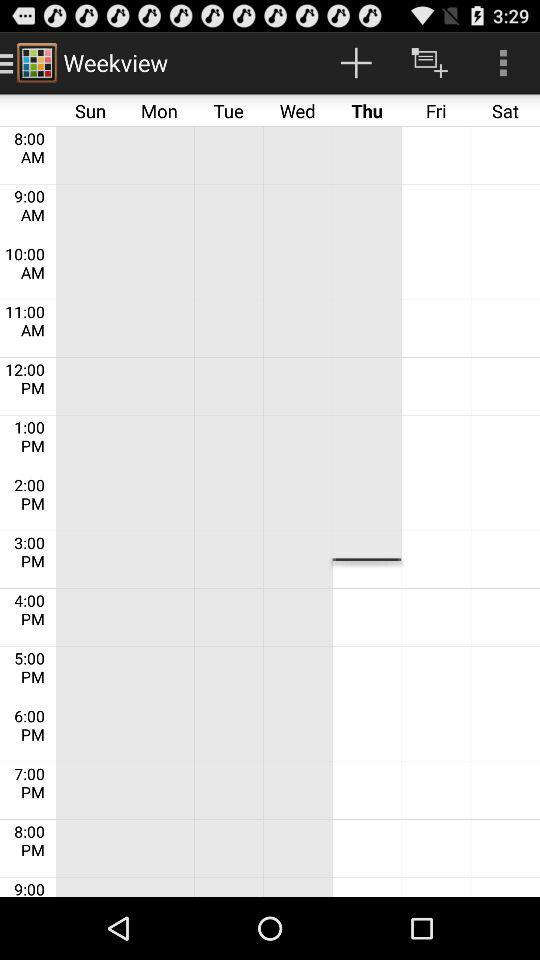Which day is selected in "Weekview"? The selected day is Thursday. 